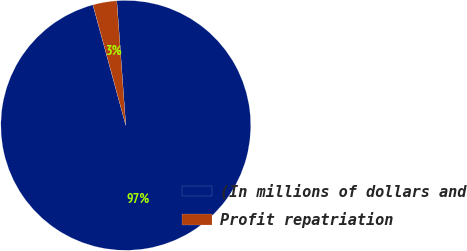<chart> <loc_0><loc_0><loc_500><loc_500><pie_chart><fcel>(In millions of dollars and<fcel>Profit repatriation<nl><fcel>96.91%<fcel>3.09%<nl></chart> 